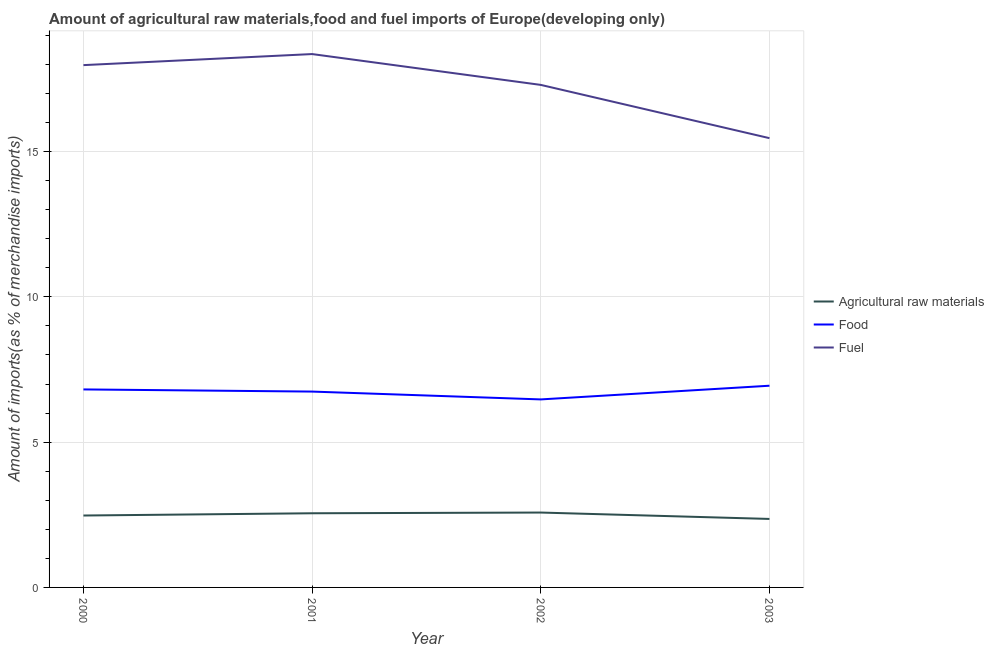What is the percentage of fuel imports in 2003?
Keep it short and to the point. 15.46. Across all years, what is the maximum percentage of raw materials imports?
Offer a terse response. 2.58. Across all years, what is the minimum percentage of food imports?
Offer a terse response. 6.47. In which year was the percentage of raw materials imports maximum?
Give a very brief answer. 2002. What is the total percentage of food imports in the graph?
Give a very brief answer. 26.97. What is the difference between the percentage of raw materials imports in 2002 and that in 2003?
Your answer should be very brief. 0.22. What is the difference between the percentage of food imports in 2003 and the percentage of raw materials imports in 2002?
Offer a terse response. 4.37. What is the average percentage of fuel imports per year?
Give a very brief answer. 17.27. In the year 2000, what is the difference between the percentage of raw materials imports and percentage of food imports?
Give a very brief answer. -4.34. In how many years, is the percentage of fuel imports greater than 14 %?
Provide a short and direct response. 4. What is the ratio of the percentage of food imports in 2000 to that in 2002?
Offer a very short reply. 1.05. What is the difference between the highest and the second highest percentage of food imports?
Your response must be concise. 0.13. What is the difference between the highest and the lowest percentage of raw materials imports?
Your response must be concise. 0.22. Is the sum of the percentage of food imports in 2001 and 2002 greater than the maximum percentage of fuel imports across all years?
Ensure brevity in your answer.  No. Does the percentage of food imports monotonically increase over the years?
Give a very brief answer. No. Is the percentage of food imports strictly less than the percentage of raw materials imports over the years?
Keep it short and to the point. No. How many lines are there?
Your answer should be compact. 3. Are the values on the major ticks of Y-axis written in scientific E-notation?
Your response must be concise. No. Does the graph contain any zero values?
Make the answer very short. No. Does the graph contain grids?
Offer a terse response. Yes. Where does the legend appear in the graph?
Provide a succinct answer. Center right. What is the title of the graph?
Give a very brief answer. Amount of agricultural raw materials,food and fuel imports of Europe(developing only). Does "Social Protection and Labor" appear as one of the legend labels in the graph?
Ensure brevity in your answer.  No. What is the label or title of the X-axis?
Offer a terse response. Year. What is the label or title of the Y-axis?
Provide a succinct answer. Amount of imports(as % of merchandise imports). What is the Amount of imports(as % of merchandise imports) in Agricultural raw materials in 2000?
Your response must be concise. 2.48. What is the Amount of imports(as % of merchandise imports) of Food in 2000?
Provide a short and direct response. 6.81. What is the Amount of imports(as % of merchandise imports) in Fuel in 2000?
Offer a terse response. 17.98. What is the Amount of imports(as % of merchandise imports) in Agricultural raw materials in 2001?
Offer a terse response. 2.55. What is the Amount of imports(as % of merchandise imports) in Food in 2001?
Keep it short and to the point. 6.74. What is the Amount of imports(as % of merchandise imports) of Fuel in 2001?
Make the answer very short. 18.36. What is the Amount of imports(as % of merchandise imports) in Agricultural raw materials in 2002?
Offer a terse response. 2.58. What is the Amount of imports(as % of merchandise imports) in Food in 2002?
Offer a very short reply. 6.47. What is the Amount of imports(as % of merchandise imports) of Fuel in 2002?
Give a very brief answer. 17.3. What is the Amount of imports(as % of merchandise imports) in Agricultural raw materials in 2003?
Keep it short and to the point. 2.36. What is the Amount of imports(as % of merchandise imports) of Food in 2003?
Keep it short and to the point. 6.94. What is the Amount of imports(as % of merchandise imports) in Fuel in 2003?
Your answer should be compact. 15.46. Across all years, what is the maximum Amount of imports(as % of merchandise imports) in Agricultural raw materials?
Your response must be concise. 2.58. Across all years, what is the maximum Amount of imports(as % of merchandise imports) of Food?
Give a very brief answer. 6.94. Across all years, what is the maximum Amount of imports(as % of merchandise imports) of Fuel?
Offer a very short reply. 18.36. Across all years, what is the minimum Amount of imports(as % of merchandise imports) in Agricultural raw materials?
Provide a short and direct response. 2.36. Across all years, what is the minimum Amount of imports(as % of merchandise imports) in Food?
Give a very brief answer. 6.47. Across all years, what is the minimum Amount of imports(as % of merchandise imports) of Fuel?
Offer a terse response. 15.46. What is the total Amount of imports(as % of merchandise imports) in Agricultural raw materials in the graph?
Your response must be concise. 9.96. What is the total Amount of imports(as % of merchandise imports) of Food in the graph?
Provide a succinct answer. 26.97. What is the total Amount of imports(as % of merchandise imports) in Fuel in the graph?
Offer a very short reply. 69.09. What is the difference between the Amount of imports(as % of merchandise imports) in Agricultural raw materials in 2000 and that in 2001?
Offer a terse response. -0.08. What is the difference between the Amount of imports(as % of merchandise imports) in Food in 2000 and that in 2001?
Your answer should be very brief. 0.07. What is the difference between the Amount of imports(as % of merchandise imports) of Fuel in 2000 and that in 2001?
Give a very brief answer. -0.38. What is the difference between the Amount of imports(as % of merchandise imports) of Agricultural raw materials in 2000 and that in 2002?
Your answer should be very brief. -0.1. What is the difference between the Amount of imports(as % of merchandise imports) of Food in 2000 and that in 2002?
Provide a succinct answer. 0.34. What is the difference between the Amount of imports(as % of merchandise imports) of Fuel in 2000 and that in 2002?
Keep it short and to the point. 0.68. What is the difference between the Amount of imports(as % of merchandise imports) of Agricultural raw materials in 2000 and that in 2003?
Your answer should be compact. 0.12. What is the difference between the Amount of imports(as % of merchandise imports) of Food in 2000 and that in 2003?
Offer a terse response. -0.13. What is the difference between the Amount of imports(as % of merchandise imports) in Fuel in 2000 and that in 2003?
Your answer should be very brief. 2.51. What is the difference between the Amount of imports(as % of merchandise imports) in Agricultural raw materials in 2001 and that in 2002?
Your answer should be compact. -0.02. What is the difference between the Amount of imports(as % of merchandise imports) in Food in 2001 and that in 2002?
Offer a very short reply. 0.27. What is the difference between the Amount of imports(as % of merchandise imports) in Fuel in 2001 and that in 2002?
Offer a terse response. 1.06. What is the difference between the Amount of imports(as % of merchandise imports) of Agricultural raw materials in 2001 and that in 2003?
Give a very brief answer. 0.2. What is the difference between the Amount of imports(as % of merchandise imports) in Food in 2001 and that in 2003?
Your response must be concise. -0.2. What is the difference between the Amount of imports(as % of merchandise imports) in Fuel in 2001 and that in 2003?
Offer a very short reply. 2.89. What is the difference between the Amount of imports(as % of merchandise imports) of Agricultural raw materials in 2002 and that in 2003?
Your answer should be very brief. 0.22. What is the difference between the Amount of imports(as % of merchandise imports) of Food in 2002 and that in 2003?
Provide a short and direct response. -0.47. What is the difference between the Amount of imports(as % of merchandise imports) of Fuel in 2002 and that in 2003?
Your answer should be compact. 1.83. What is the difference between the Amount of imports(as % of merchandise imports) in Agricultural raw materials in 2000 and the Amount of imports(as % of merchandise imports) in Food in 2001?
Make the answer very short. -4.27. What is the difference between the Amount of imports(as % of merchandise imports) of Agricultural raw materials in 2000 and the Amount of imports(as % of merchandise imports) of Fuel in 2001?
Make the answer very short. -15.88. What is the difference between the Amount of imports(as % of merchandise imports) of Food in 2000 and the Amount of imports(as % of merchandise imports) of Fuel in 2001?
Make the answer very short. -11.54. What is the difference between the Amount of imports(as % of merchandise imports) of Agricultural raw materials in 2000 and the Amount of imports(as % of merchandise imports) of Food in 2002?
Your response must be concise. -4. What is the difference between the Amount of imports(as % of merchandise imports) of Agricultural raw materials in 2000 and the Amount of imports(as % of merchandise imports) of Fuel in 2002?
Make the answer very short. -14.82. What is the difference between the Amount of imports(as % of merchandise imports) in Food in 2000 and the Amount of imports(as % of merchandise imports) in Fuel in 2002?
Offer a very short reply. -10.48. What is the difference between the Amount of imports(as % of merchandise imports) in Agricultural raw materials in 2000 and the Amount of imports(as % of merchandise imports) in Food in 2003?
Provide a short and direct response. -4.47. What is the difference between the Amount of imports(as % of merchandise imports) in Agricultural raw materials in 2000 and the Amount of imports(as % of merchandise imports) in Fuel in 2003?
Your answer should be very brief. -12.99. What is the difference between the Amount of imports(as % of merchandise imports) of Food in 2000 and the Amount of imports(as % of merchandise imports) of Fuel in 2003?
Provide a short and direct response. -8.65. What is the difference between the Amount of imports(as % of merchandise imports) in Agricultural raw materials in 2001 and the Amount of imports(as % of merchandise imports) in Food in 2002?
Your answer should be very brief. -3.92. What is the difference between the Amount of imports(as % of merchandise imports) in Agricultural raw materials in 2001 and the Amount of imports(as % of merchandise imports) in Fuel in 2002?
Offer a terse response. -14.74. What is the difference between the Amount of imports(as % of merchandise imports) in Food in 2001 and the Amount of imports(as % of merchandise imports) in Fuel in 2002?
Provide a short and direct response. -10.56. What is the difference between the Amount of imports(as % of merchandise imports) of Agricultural raw materials in 2001 and the Amount of imports(as % of merchandise imports) of Food in 2003?
Provide a succinct answer. -4.39. What is the difference between the Amount of imports(as % of merchandise imports) of Agricultural raw materials in 2001 and the Amount of imports(as % of merchandise imports) of Fuel in 2003?
Provide a succinct answer. -12.91. What is the difference between the Amount of imports(as % of merchandise imports) in Food in 2001 and the Amount of imports(as % of merchandise imports) in Fuel in 2003?
Offer a very short reply. -8.72. What is the difference between the Amount of imports(as % of merchandise imports) of Agricultural raw materials in 2002 and the Amount of imports(as % of merchandise imports) of Food in 2003?
Provide a short and direct response. -4.37. What is the difference between the Amount of imports(as % of merchandise imports) in Agricultural raw materials in 2002 and the Amount of imports(as % of merchandise imports) in Fuel in 2003?
Your response must be concise. -12.89. What is the difference between the Amount of imports(as % of merchandise imports) of Food in 2002 and the Amount of imports(as % of merchandise imports) of Fuel in 2003?
Provide a short and direct response. -8.99. What is the average Amount of imports(as % of merchandise imports) of Agricultural raw materials per year?
Ensure brevity in your answer.  2.49. What is the average Amount of imports(as % of merchandise imports) of Food per year?
Keep it short and to the point. 6.74. What is the average Amount of imports(as % of merchandise imports) in Fuel per year?
Your response must be concise. 17.27. In the year 2000, what is the difference between the Amount of imports(as % of merchandise imports) of Agricultural raw materials and Amount of imports(as % of merchandise imports) of Food?
Ensure brevity in your answer.  -4.34. In the year 2000, what is the difference between the Amount of imports(as % of merchandise imports) of Agricultural raw materials and Amount of imports(as % of merchandise imports) of Fuel?
Keep it short and to the point. -15.5. In the year 2000, what is the difference between the Amount of imports(as % of merchandise imports) in Food and Amount of imports(as % of merchandise imports) in Fuel?
Make the answer very short. -11.16. In the year 2001, what is the difference between the Amount of imports(as % of merchandise imports) of Agricultural raw materials and Amount of imports(as % of merchandise imports) of Food?
Provide a short and direct response. -4.19. In the year 2001, what is the difference between the Amount of imports(as % of merchandise imports) of Agricultural raw materials and Amount of imports(as % of merchandise imports) of Fuel?
Give a very brief answer. -15.8. In the year 2001, what is the difference between the Amount of imports(as % of merchandise imports) in Food and Amount of imports(as % of merchandise imports) in Fuel?
Your answer should be compact. -11.62. In the year 2002, what is the difference between the Amount of imports(as % of merchandise imports) in Agricultural raw materials and Amount of imports(as % of merchandise imports) in Food?
Your response must be concise. -3.89. In the year 2002, what is the difference between the Amount of imports(as % of merchandise imports) of Agricultural raw materials and Amount of imports(as % of merchandise imports) of Fuel?
Offer a terse response. -14.72. In the year 2002, what is the difference between the Amount of imports(as % of merchandise imports) in Food and Amount of imports(as % of merchandise imports) in Fuel?
Your answer should be compact. -10.82. In the year 2003, what is the difference between the Amount of imports(as % of merchandise imports) of Agricultural raw materials and Amount of imports(as % of merchandise imports) of Food?
Make the answer very short. -4.59. In the year 2003, what is the difference between the Amount of imports(as % of merchandise imports) of Agricultural raw materials and Amount of imports(as % of merchandise imports) of Fuel?
Keep it short and to the point. -13.11. In the year 2003, what is the difference between the Amount of imports(as % of merchandise imports) of Food and Amount of imports(as % of merchandise imports) of Fuel?
Keep it short and to the point. -8.52. What is the ratio of the Amount of imports(as % of merchandise imports) of Agricultural raw materials in 2000 to that in 2001?
Make the answer very short. 0.97. What is the ratio of the Amount of imports(as % of merchandise imports) of Fuel in 2000 to that in 2001?
Provide a succinct answer. 0.98. What is the ratio of the Amount of imports(as % of merchandise imports) of Agricultural raw materials in 2000 to that in 2002?
Make the answer very short. 0.96. What is the ratio of the Amount of imports(as % of merchandise imports) in Food in 2000 to that in 2002?
Your response must be concise. 1.05. What is the ratio of the Amount of imports(as % of merchandise imports) in Fuel in 2000 to that in 2002?
Provide a short and direct response. 1.04. What is the ratio of the Amount of imports(as % of merchandise imports) in Agricultural raw materials in 2000 to that in 2003?
Make the answer very short. 1.05. What is the ratio of the Amount of imports(as % of merchandise imports) of Food in 2000 to that in 2003?
Your answer should be compact. 0.98. What is the ratio of the Amount of imports(as % of merchandise imports) in Fuel in 2000 to that in 2003?
Give a very brief answer. 1.16. What is the ratio of the Amount of imports(as % of merchandise imports) of Food in 2001 to that in 2002?
Offer a terse response. 1.04. What is the ratio of the Amount of imports(as % of merchandise imports) in Fuel in 2001 to that in 2002?
Your response must be concise. 1.06. What is the ratio of the Amount of imports(as % of merchandise imports) of Agricultural raw materials in 2001 to that in 2003?
Provide a succinct answer. 1.08. What is the ratio of the Amount of imports(as % of merchandise imports) in Food in 2001 to that in 2003?
Make the answer very short. 0.97. What is the ratio of the Amount of imports(as % of merchandise imports) in Fuel in 2001 to that in 2003?
Make the answer very short. 1.19. What is the ratio of the Amount of imports(as % of merchandise imports) in Agricultural raw materials in 2002 to that in 2003?
Keep it short and to the point. 1.09. What is the ratio of the Amount of imports(as % of merchandise imports) in Food in 2002 to that in 2003?
Your response must be concise. 0.93. What is the ratio of the Amount of imports(as % of merchandise imports) in Fuel in 2002 to that in 2003?
Offer a terse response. 1.12. What is the difference between the highest and the second highest Amount of imports(as % of merchandise imports) of Agricultural raw materials?
Keep it short and to the point. 0.02. What is the difference between the highest and the second highest Amount of imports(as % of merchandise imports) of Food?
Keep it short and to the point. 0.13. What is the difference between the highest and the second highest Amount of imports(as % of merchandise imports) in Fuel?
Provide a succinct answer. 0.38. What is the difference between the highest and the lowest Amount of imports(as % of merchandise imports) in Agricultural raw materials?
Give a very brief answer. 0.22. What is the difference between the highest and the lowest Amount of imports(as % of merchandise imports) of Food?
Make the answer very short. 0.47. What is the difference between the highest and the lowest Amount of imports(as % of merchandise imports) in Fuel?
Provide a succinct answer. 2.89. 